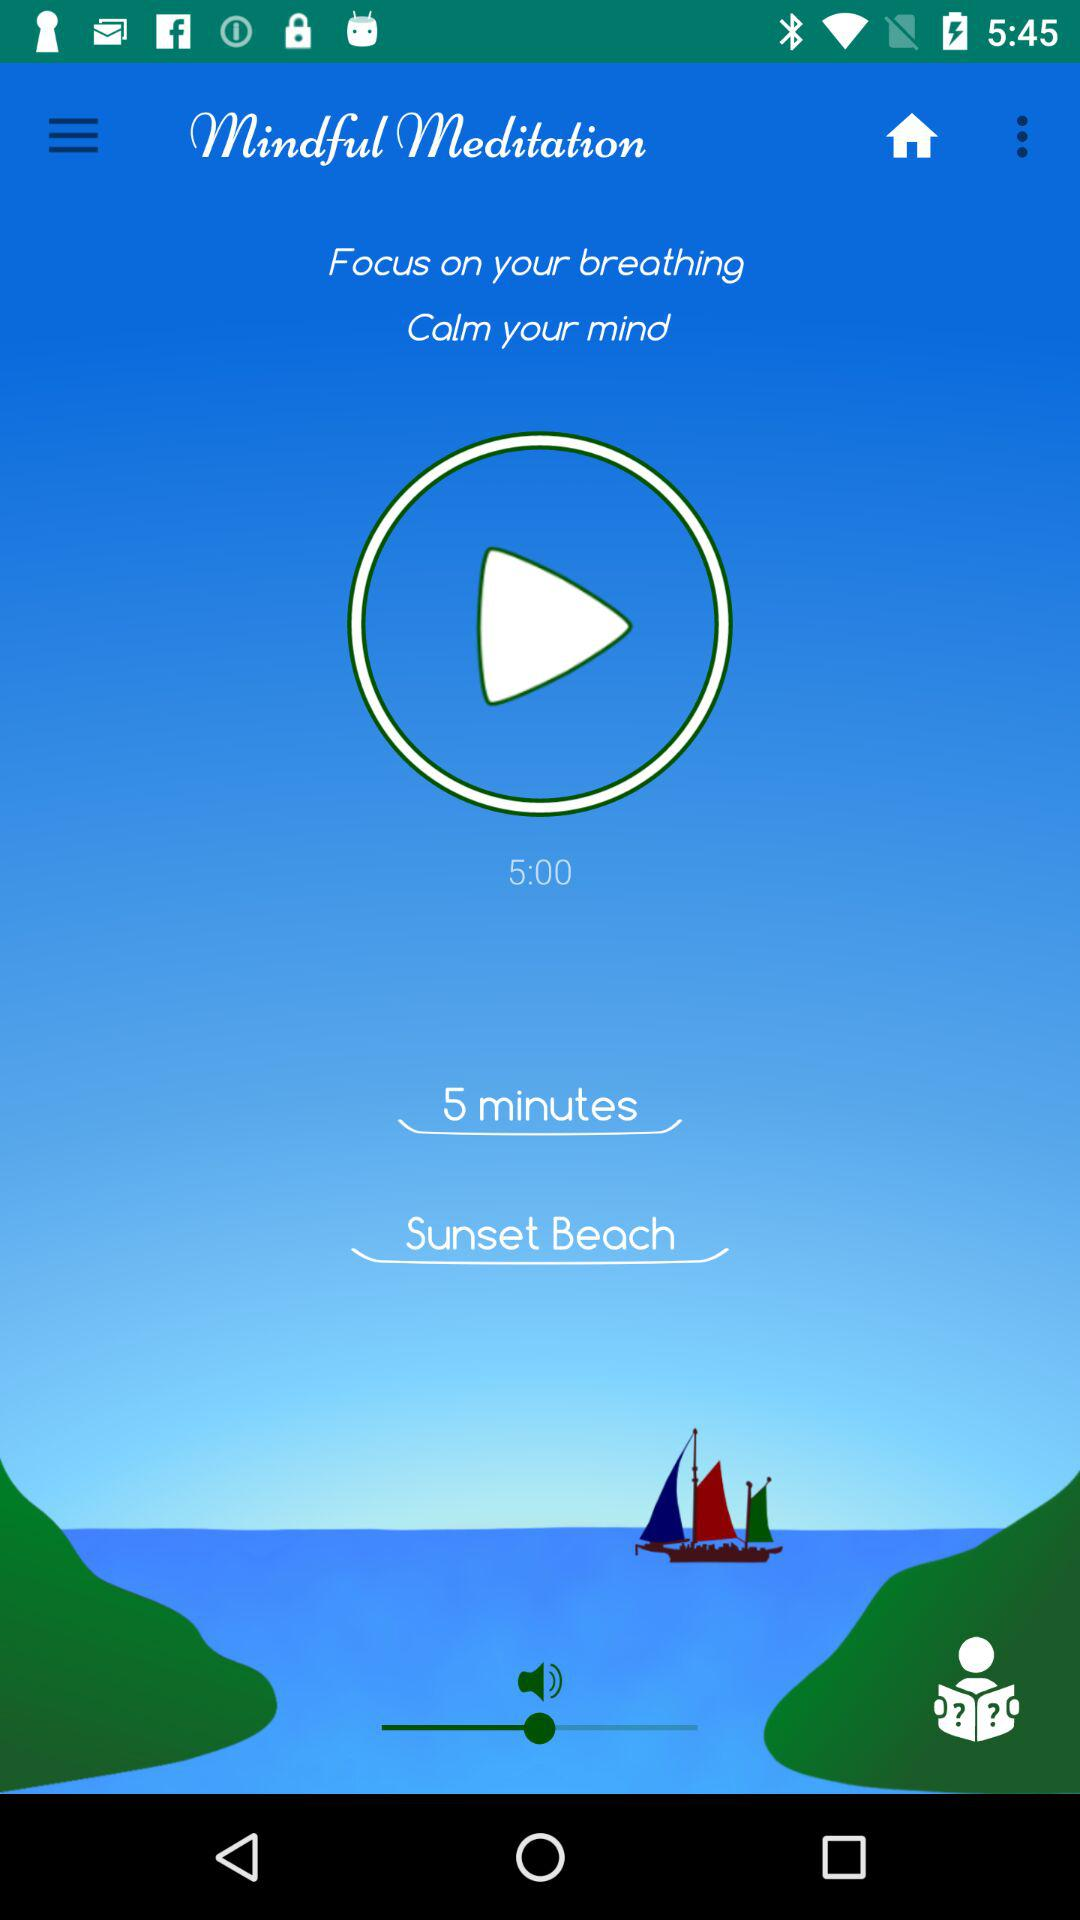What is the application name? The application name is "Mindful Meditation". 